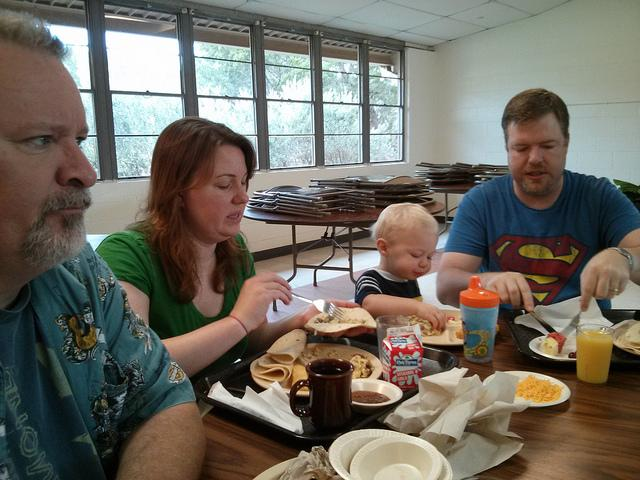What did the man with an S on his shirt likely read when he was young? comics 